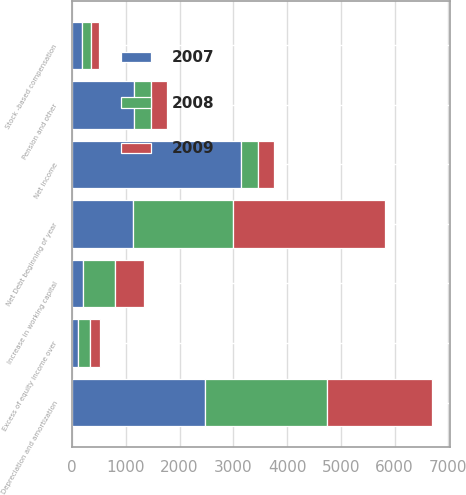Convert chart. <chart><loc_0><loc_0><loc_500><loc_500><stacked_bar_chart><ecel><fcel>Net Debt beginning of year<fcel>Net income<fcel>Depreciation and amortization<fcel>Pension and other<fcel>Excess of equity income over<fcel>Stock -based compensation<fcel>Increase in working capital<nl><fcel>2007<fcel>1129<fcel>3142<fcel>2476<fcel>1149<fcel>103<fcel>186<fcel>204<nl><fcel>2008<fcel>1857<fcel>312<fcel>2269<fcel>318<fcel>235<fcel>172<fcel>592<nl><fcel>2009<fcel>2834<fcel>312<fcel>1954<fcel>294<fcel>189<fcel>136<fcel>541<nl></chart> 